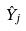<formula> <loc_0><loc_0><loc_500><loc_500>\hat { Y } _ { j }</formula> 